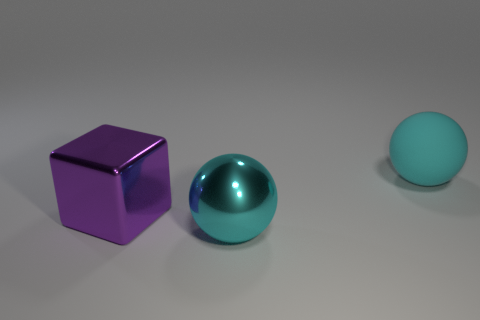What is the color of the thing that is in front of the rubber ball and to the right of the purple cube?
Your response must be concise. Cyan. There is a cyan ball to the right of the cyan metal object; is its size the same as the shiny ball?
Offer a very short reply. Yes. Is there a large cyan thing right of the cyan sphere that is behind the large metallic ball?
Your answer should be compact. No. What material is the large purple block?
Ensure brevity in your answer.  Metal. Are there any purple objects right of the big cyan matte thing?
Offer a terse response. No. What is the size of the other cyan object that is the same shape as the rubber object?
Your response must be concise. Large. Are there the same number of big purple metal cubes on the left side of the big purple metal block and big cyan spheres that are behind the cyan matte sphere?
Give a very brief answer. Yes. How many large green matte things are there?
Your answer should be very brief. 0. Is the number of big purple metal objects that are in front of the big purple object greater than the number of tiny green shiny cylinders?
Keep it short and to the point. No. There is a big sphere behind the metal sphere; what is it made of?
Ensure brevity in your answer.  Rubber. 